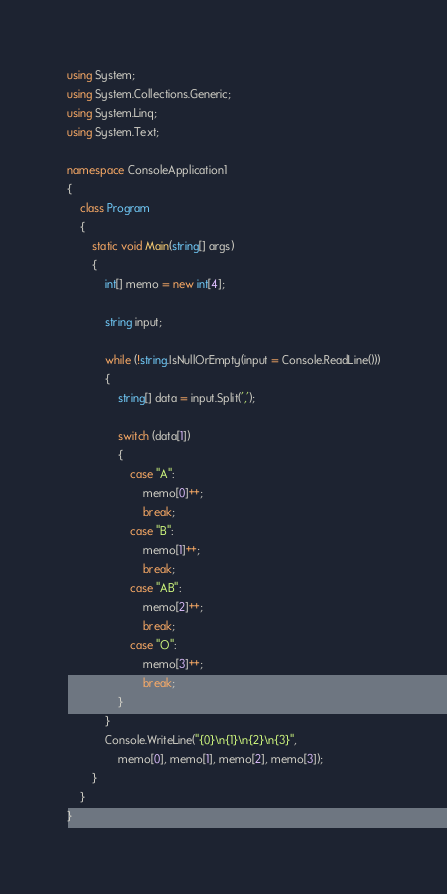<code> <loc_0><loc_0><loc_500><loc_500><_C#_>using System;
using System.Collections.Generic;
using System.Linq;
using System.Text;

namespace ConsoleApplication1
{
    class Program
    {
        static void Main(string[] args)
        {
            int[] memo = new int[4];

            string input;

            while (!string.IsNullOrEmpty(input = Console.ReadLine()))
            {
                string[] data = input.Split(',');

                switch (data[1])
                {
                    case "A":
                        memo[0]++;
                        break;
                    case "B":
                        memo[1]++;
                        break;
                    case "AB":
                        memo[2]++;
                        break;
                    case "O":
                        memo[3]++;
                        break;
                }
            }
            Console.WriteLine("{0}\n{1}\n{2}\n{3}",
                memo[0], memo[1], memo[2], memo[3]);
        }
    }
}</code> 